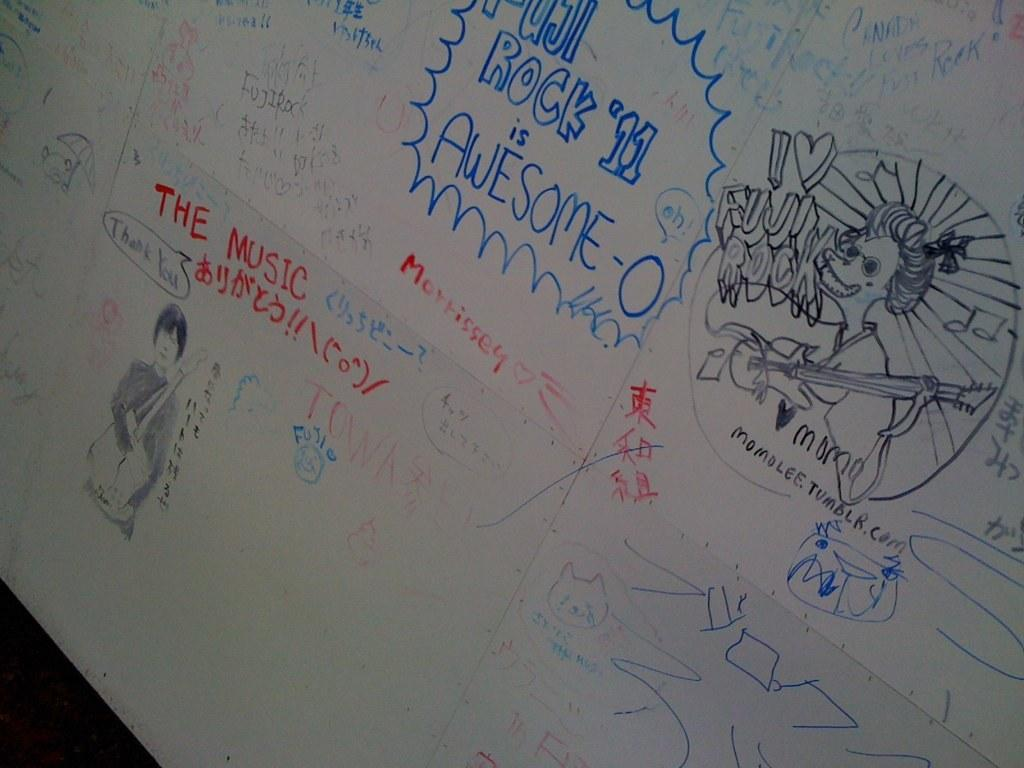What type of artwork is visible in the image? There are sketches in the image. What medium was used to create the sketches? The sketches are drawn with color pencils. What additional text can be seen in the image? There are proverbs and quotes in the image. Where is the unit located in the image? There is no unit present in the image. What type of wood is used to create the lunchroom table in the image? There is no lunchroom table present in the image. 